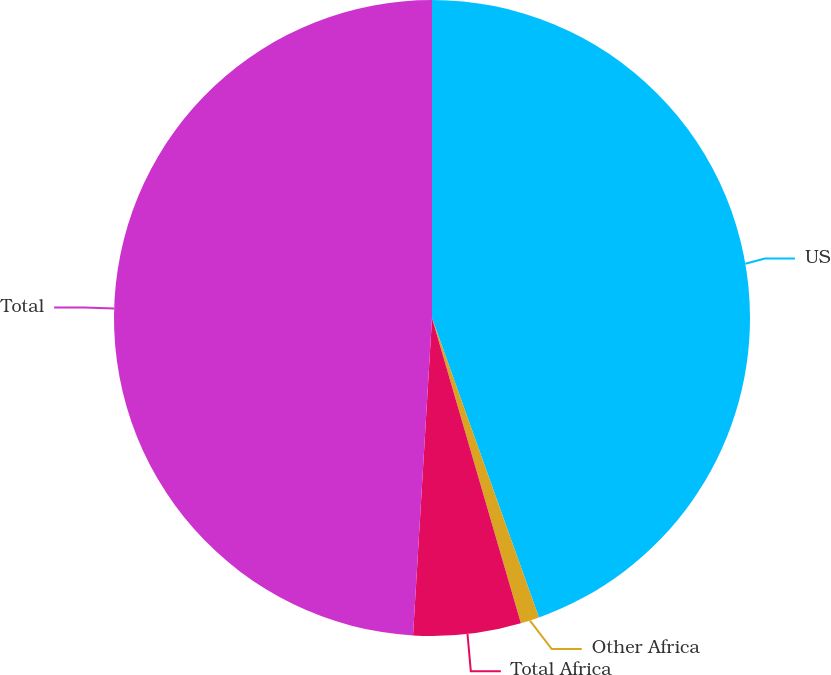Convert chart to OTSL. <chart><loc_0><loc_0><loc_500><loc_500><pie_chart><fcel>US<fcel>Other Africa<fcel>Total Africa<fcel>Total<nl><fcel>44.54%<fcel>0.95%<fcel>5.46%<fcel>49.05%<nl></chart> 